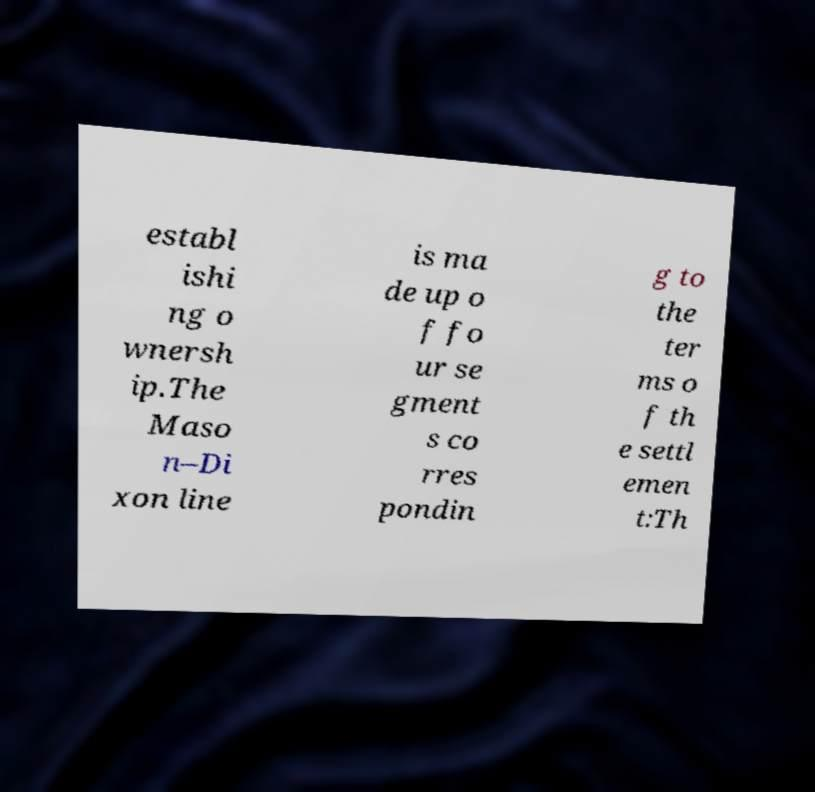I need the written content from this picture converted into text. Can you do that? establ ishi ng o wnersh ip.The Maso n–Di xon line is ma de up o f fo ur se gment s co rres pondin g to the ter ms o f th e settl emen t:Th 